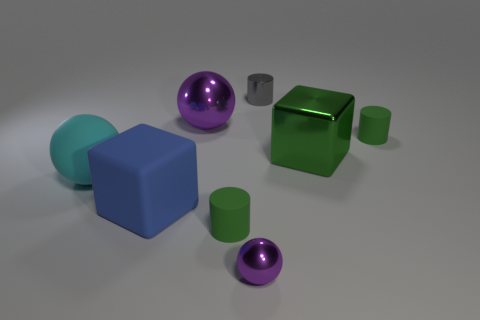Add 2 big metal cubes. How many objects exist? 10 Subtract all cylinders. How many objects are left? 5 Subtract all big things. Subtract all small green matte things. How many objects are left? 2 Add 5 blue cubes. How many blue cubes are left? 6 Add 7 large green objects. How many large green objects exist? 8 Subtract 2 green cylinders. How many objects are left? 6 